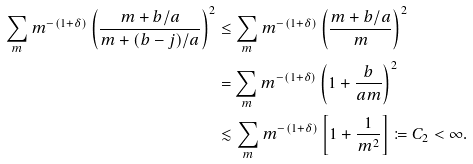Convert formula to latex. <formula><loc_0><loc_0><loc_500><loc_500>\sum _ { m } m ^ { - ( 1 + \delta ) } \left ( \frac { m + b / a } { m + ( b - j ) / a } \right ) ^ { 2 } & \leq \sum _ { m } m ^ { - ( 1 + \delta ) } \left ( \frac { m + b / a } { m } \right ) ^ { 2 } \\ & = \sum _ { m } m ^ { - ( 1 + \delta ) } \left ( 1 + \frac { b } { a m } \right ) ^ { 2 } \\ & \lesssim \sum _ { m } m ^ { - ( 1 + \delta ) } \left [ 1 + \frac { 1 } { m ^ { 2 } } \right ] \coloneqq C _ { 2 } < \infty .</formula> 